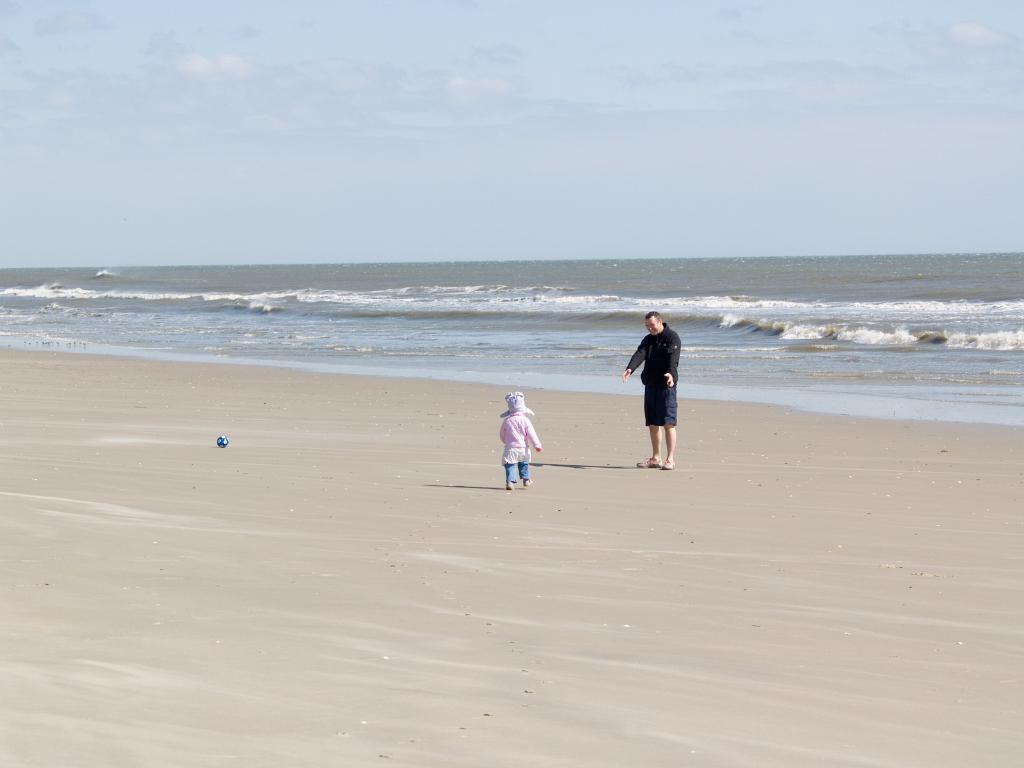Describe this image in one or two sentences. In the foreground of this image, there is a kid and a man on the sand. We can also see a ball on the sand. In the background, there is water and the sky. 